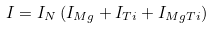<formula> <loc_0><loc_0><loc_500><loc_500>I = I _ { N } \left ( I _ { M g } + I _ { T i } + I _ { M g T i } \right )</formula> 